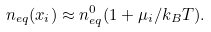<formula> <loc_0><loc_0><loc_500><loc_500>n _ { e q } ( x _ { i } ) \approx n ^ { 0 } _ { e q } ( 1 + \mu _ { i } / k _ { B } T ) .</formula> 